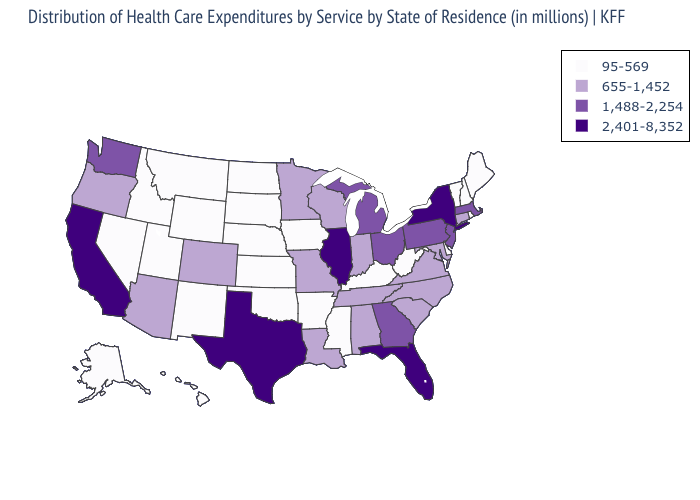What is the highest value in the USA?
Concise answer only. 2,401-8,352. Name the states that have a value in the range 655-1,452?
Keep it brief. Alabama, Arizona, Colorado, Connecticut, Indiana, Louisiana, Maryland, Minnesota, Missouri, North Carolina, Oregon, South Carolina, Tennessee, Virginia, Wisconsin. What is the highest value in states that border Ohio?
Answer briefly. 1,488-2,254. Name the states that have a value in the range 655-1,452?
Give a very brief answer. Alabama, Arizona, Colorado, Connecticut, Indiana, Louisiana, Maryland, Minnesota, Missouri, North Carolina, Oregon, South Carolina, Tennessee, Virginia, Wisconsin. Does Pennsylvania have the lowest value in the USA?
Concise answer only. No. Name the states that have a value in the range 2,401-8,352?
Quick response, please. California, Florida, Illinois, New York, Texas. Name the states that have a value in the range 655-1,452?
Quick response, please. Alabama, Arizona, Colorado, Connecticut, Indiana, Louisiana, Maryland, Minnesota, Missouri, North Carolina, Oregon, South Carolina, Tennessee, Virginia, Wisconsin. What is the lowest value in the West?
Concise answer only. 95-569. Among the states that border North Carolina , which have the lowest value?
Write a very short answer. South Carolina, Tennessee, Virginia. Which states have the lowest value in the South?
Answer briefly. Arkansas, Delaware, Kentucky, Mississippi, Oklahoma, West Virginia. What is the value of Kansas?
Concise answer only. 95-569. Does Oklahoma have the lowest value in the USA?
Give a very brief answer. Yes. Does Montana have the highest value in the West?
Give a very brief answer. No. Does Oklahoma have the lowest value in the USA?
Short answer required. Yes. What is the value of Missouri?
Answer briefly. 655-1,452. 